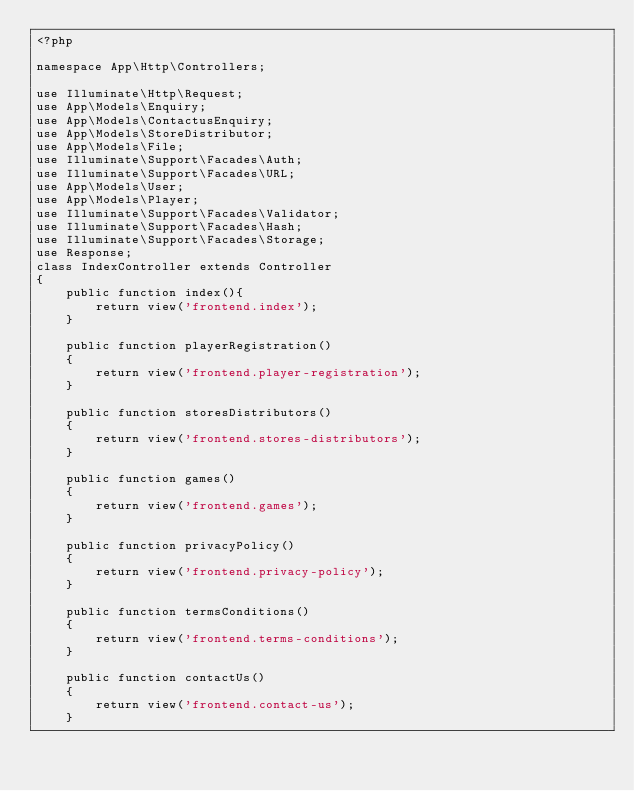<code> <loc_0><loc_0><loc_500><loc_500><_PHP_><?php

namespace App\Http\Controllers;

use Illuminate\Http\Request;
use App\Models\Enquiry;
use App\Models\ContactusEnquiry;
use App\Models\StoreDistributor;
use App\Models\File;
use Illuminate\Support\Facades\Auth;
use Illuminate\Support\Facades\URL;
use App\Models\User;
use App\Models\Player;
use Illuminate\Support\Facades\Validator;
use Illuminate\Support\Facades\Hash;
use Illuminate\Support\Facades\Storage;
use Response;
class IndexController extends Controller
{
    public function index(){
        return view('frontend.index');
    }

    public function playerRegistration()
    {
        return view('frontend.player-registration');
    }

    public function storesDistributors()
    {
        return view('frontend.stores-distributors');
    }

    public function games()
    {
        return view('frontend.games');
    }

    public function privacyPolicy()
    {
        return view('frontend.privacy-policy');
    }

    public function termsConditions()
    {
        return view('frontend.terms-conditions');
    }

    public function contactUs()
    {
        return view('frontend.contact-us');
    }
</code> 